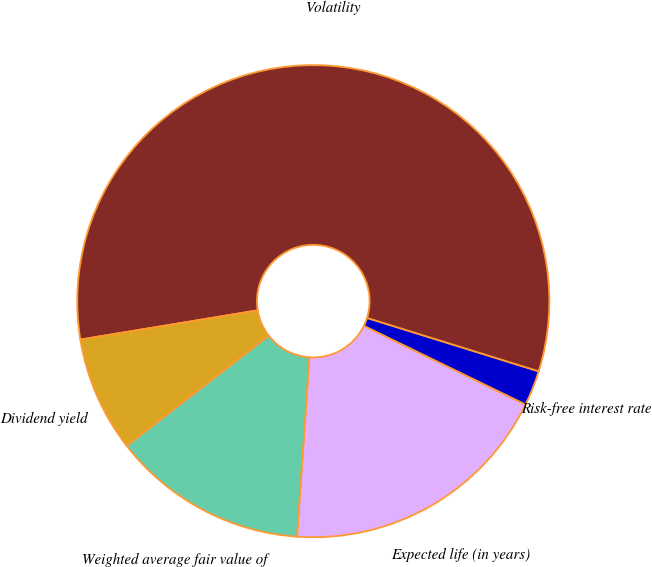Convert chart to OTSL. <chart><loc_0><loc_0><loc_500><loc_500><pie_chart><fcel>Expected life (in years)<fcel>Risk-free interest rate<fcel>Volatility<fcel>Dividend yield<fcel>Weighted average fair value of<nl><fcel>18.89%<fcel>2.41%<fcel>57.4%<fcel>7.9%<fcel>13.4%<nl></chart> 